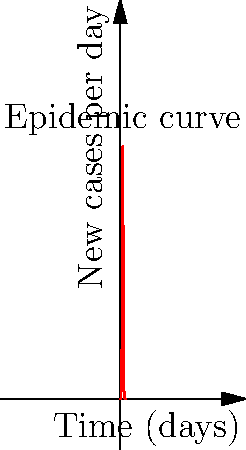An infectious disease outbreak follows the epidemic curve shown above. The number of new cases per day can be modeled by the function $f(t) = 1000e^{-0.1(t-10)^2}$, where $t$ is the number of days since the outbreak began. Calculate the total number of cases that occurred during the first 20 days of the outbreak. To find the total number of cases over the 20-day period, we need to calculate the area under the epidemic curve from $t=0$ to $t=20$. This can be done using a definite integral:

1) Set up the integral:
   $$\int_0^{20} 1000e^{-0.1(t-10)^2} dt$$

2) This integral cannot be solved using elementary antiderivatives. We need to use numerical integration methods.

3) One approach is to use the trapezoidal rule with a small step size, for example, $\Delta t = 0.1$:

   $$\text{Area} \approx 0.1 \sum_{i=0}^{199} \frac{f(0.1i) + f(0.1(i+1))}{2}$$

4) Using a computer or calculator to perform this calculation, we get:

   Total cases ≈ 3989.42

5) Rounding to the nearest whole number, as we're dealing with cases of disease:

   Total cases ≈ 3989
Answer: 3989 cases 